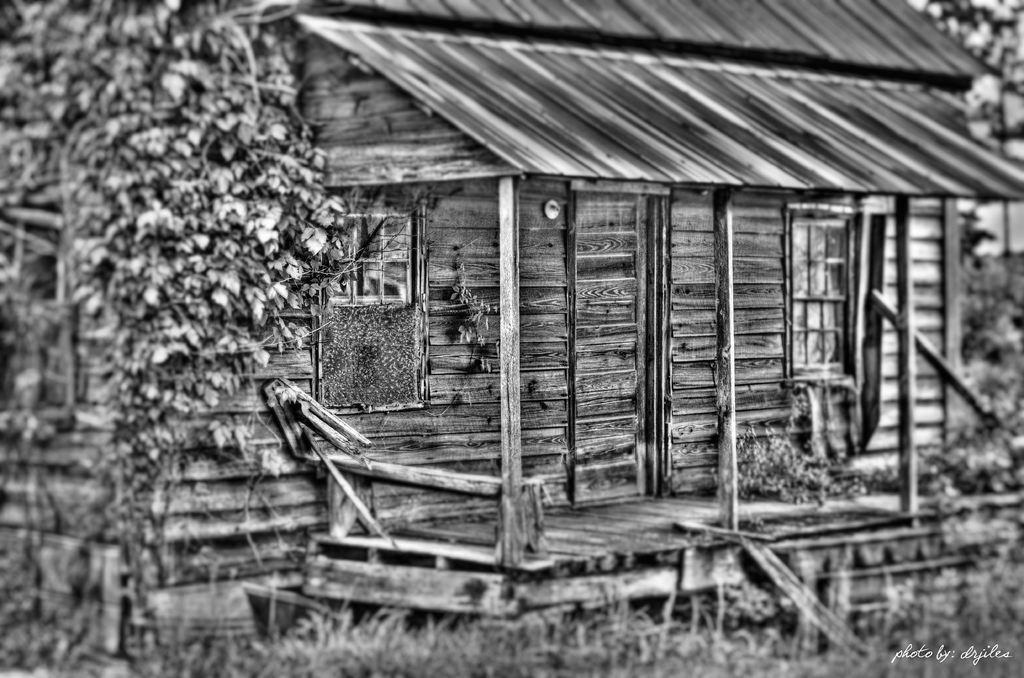Please provide a concise description of this image. In the image we can see a wooden house. These are the stairs, grass, tree and a window. 